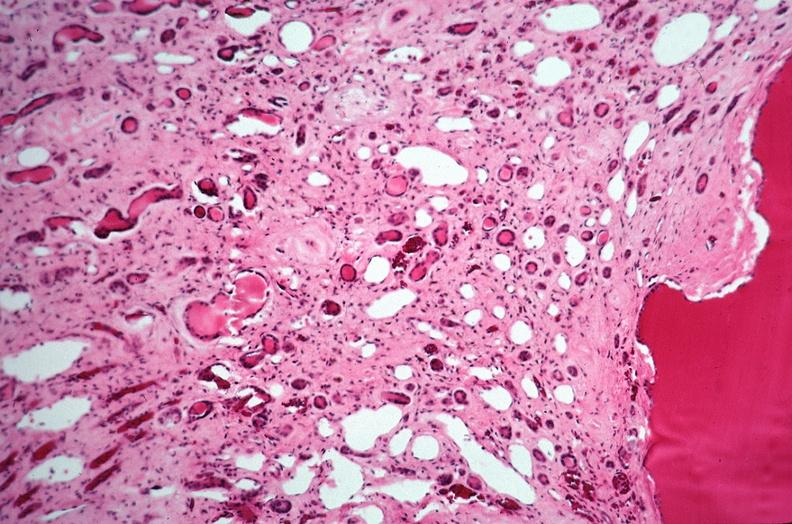does this image show kidney, adult polycystic kidney?
Answer the question using a single word or phrase. Yes 